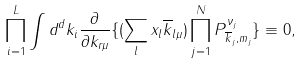Convert formula to latex. <formula><loc_0><loc_0><loc_500><loc_500>\prod _ { i = 1 } ^ { L } \int d ^ { d } k _ { i } \frac { \partial } { \partial k _ { r \mu } } \{ ( \sum _ { l } x _ { l } \overline { k } _ { l \mu } ) \prod _ { j = 1 } ^ { N } P _ { \overline { k } _ { j } , m _ { j } } ^ { \nu _ { j } } \} \equiv 0 ,</formula> 